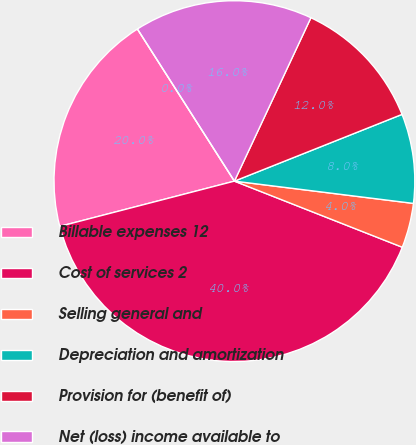<chart> <loc_0><loc_0><loc_500><loc_500><pie_chart><fcel>Billable expenses 12<fcel>Cost of services 2<fcel>Selling general and<fcel>Depreciation and amortization<fcel>Provision for (benefit of)<fcel>Net (loss) income available to<fcel>Dividends declared per common<nl><fcel>20.0%<fcel>39.99%<fcel>4.0%<fcel>8.0%<fcel>12.0%<fcel>16.0%<fcel>0.0%<nl></chart> 